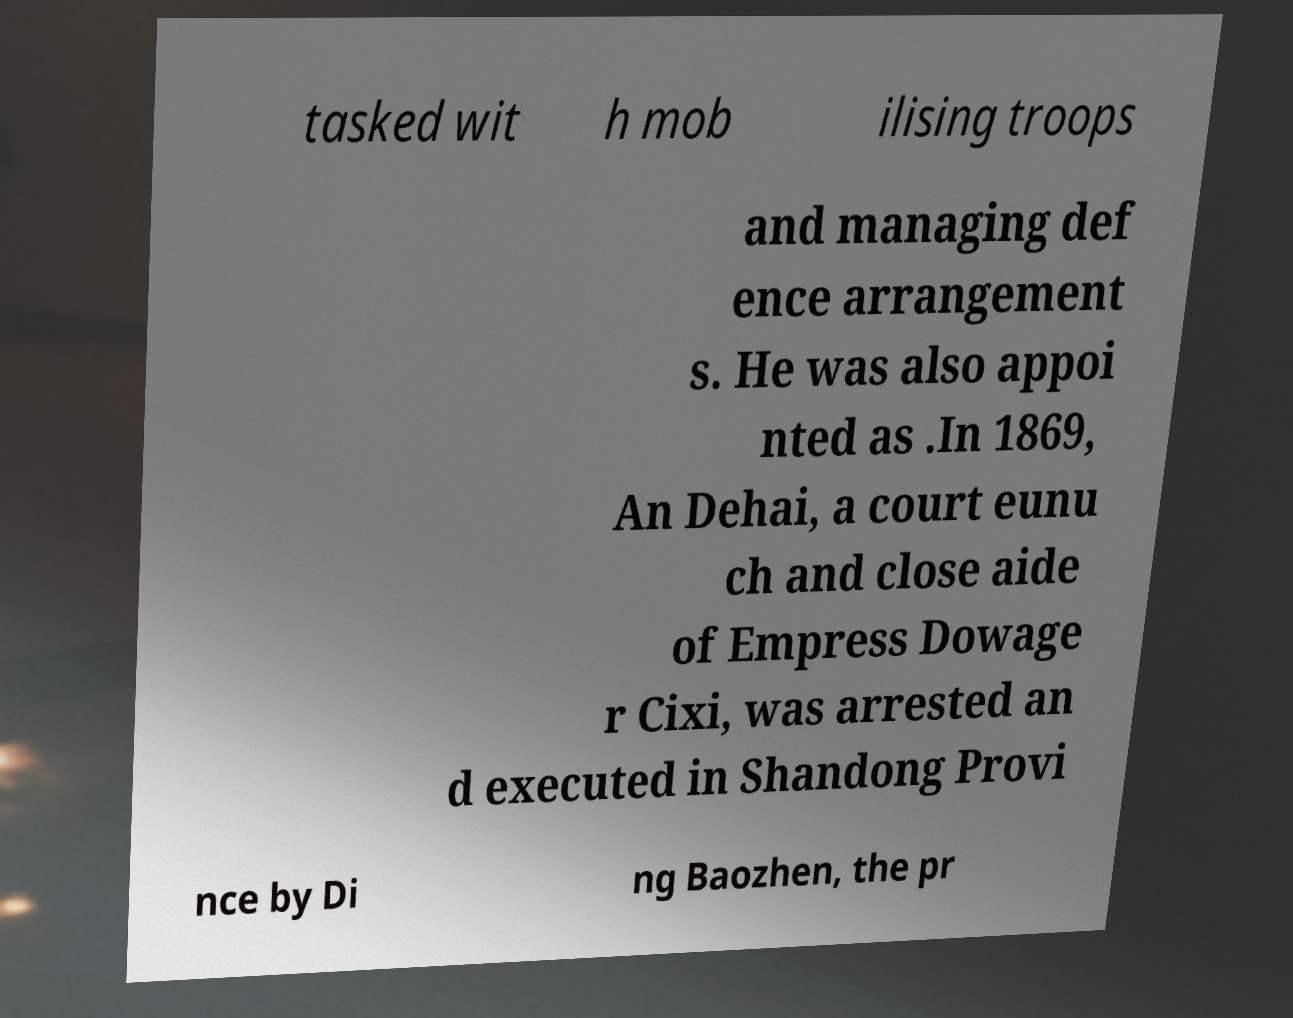Can you read and provide the text displayed in the image?This photo seems to have some interesting text. Can you extract and type it out for me? tasked wit h mob ilising troops and managing def ence arrangement s. He was also appoi nted as .In 1869, An Dehai, a court eunu ch and close aide of Empress Dowage r Cixi, was arrested an d executed in Shandong Provi nce by Di ng Baozhen, the pr 